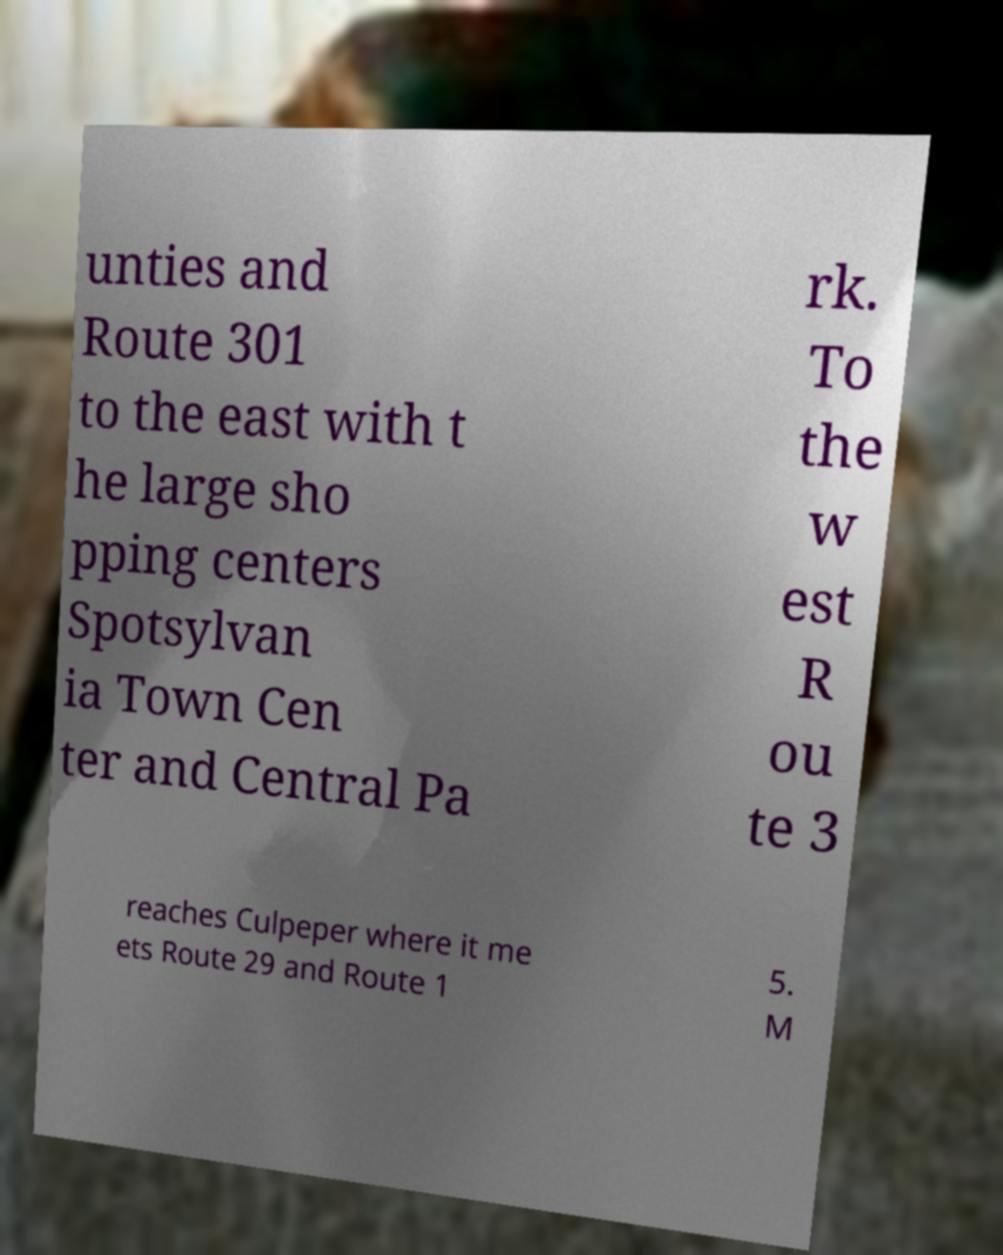What messages or text are displayed in this image? I need them in a readable, typed format. unties and Route 301 to the east with t he large sho pping centers Spotsylvan ia Town Cen ter and Central Pa rk. To the w est R ou te 3 reaches Culpeper where it me ets Route 29 and Route 1 5. M 